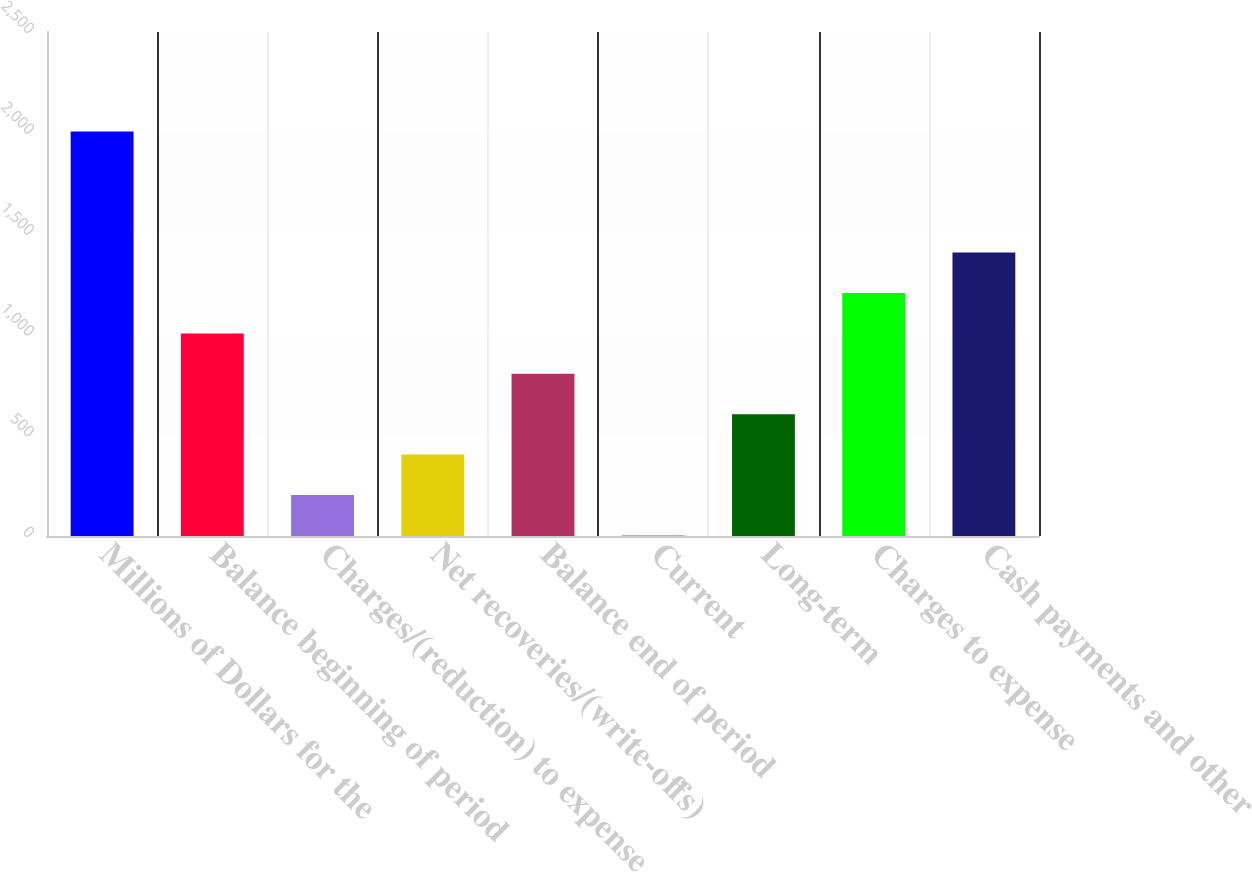Convert chart. <chart><loc_0><loc_0><loc_500><loc_500><bar_chart><fcel>Millions of Dollars for the<fcel>Balance beginning of period<fcel>Charges/(reduction) to expense<fcel>Net recoveries/(write-offs)<fcel>Balance end of period<fcel>Current<fcel>Long-term<fcel>Charges to expense<fcel>Cash payments and other<nl><fcel>2007<fcel>1005<fcel>203.4<fcel>403.8<fcel>804.6<fcel>3<fcel>604.2<fcel>1205.4<fcel>1405.8<nl></chart> 